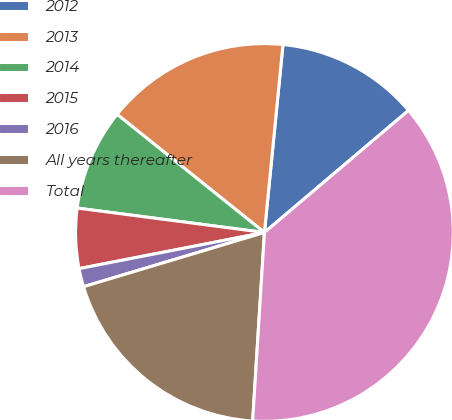Convert chart to OTSL. <chart><loc_0><loc_0><loc_500><loc_500><pie_chart><fcel>2012<fcel>2013<fcel>2014<fcel>2015<fcel>2016<fcel>All years thereafter<fcel>Total<nl><fcel>12.25%<fcel>15.81%<fcel>8.69%<fcel>5.13%<fcel>1.57%<fcel>19.37%<fcel>37.18%<nl></chart> 